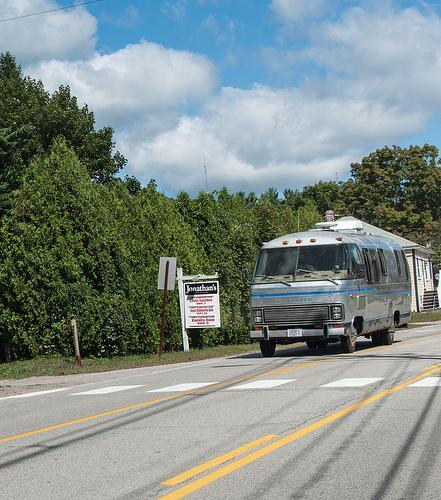Mention the parts of the motor home that are emphasized in the image.  Four headlights, license plate, windshield wiper, and reflector grouping atop the motor home are emphasized. Provide a brief description of the house's location in relation to the other objects in the image. The house is behind the camper and partially obstructed by it, with trees behind the house and stairs in front. Give a brief overview of the scene in the image, including the main elements. The image shows a paved road lined with trees and signs, featuring a silver camper, a house in the distance, a cloudy sky, and various road markings. What color is the camper on the road and what vehicle type is it? The camper is silver and it is a recreational vehicle. List three objects found along the sides of the road in this image. Two signs, trees, and a white wooden street sign. Describe the sky in the image and whether it is clear or cloudy. The sky in the image is a cloudy blue with white fair-weather clouds. Identify the type of sign next to the motor home and what it might be for. It is a white swinging sign that appears to advertise local businesses. How many road signs are there in the image and what are they made of? There are three road signs, two made of metal and one made of wood. Write a sentence describing the road and its markings in the image. The paved road features a long yellow painted line, a white painted crosswalk, and a driveway coming off the side. Count the total number of yellow lines on the road in the image. There are three yellow lines on the road. 